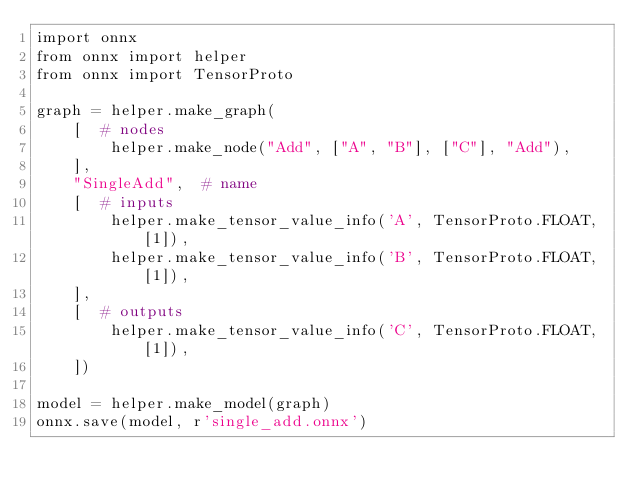Convert code to text. <code><loc_0><loc_0><loc_500><loc_500><_Python_>import onnx
from onnx import helper
from onnx import TensorProto

graph = helper.make_graph(
    [  # nodes
        helper.make_node("Add", ["A", "B"], ["C"], "Add"),
    ],
    "SingleAdd",  # name
    [  # inputs
        helper.make_tensor_value_info('A', TensorProto.FLOAT, [1]),
        helper.make_tensor_value_info('B', TensorProto.FLOAT, [1]),
    ],
    [  # outputs
        helper.make_tensor_value_info('C', TensorProto.FLOAT, [1]),
    ])

model = helper.make_model(graph)
onnx.save(model, r'single_add.onnx')
</code> 